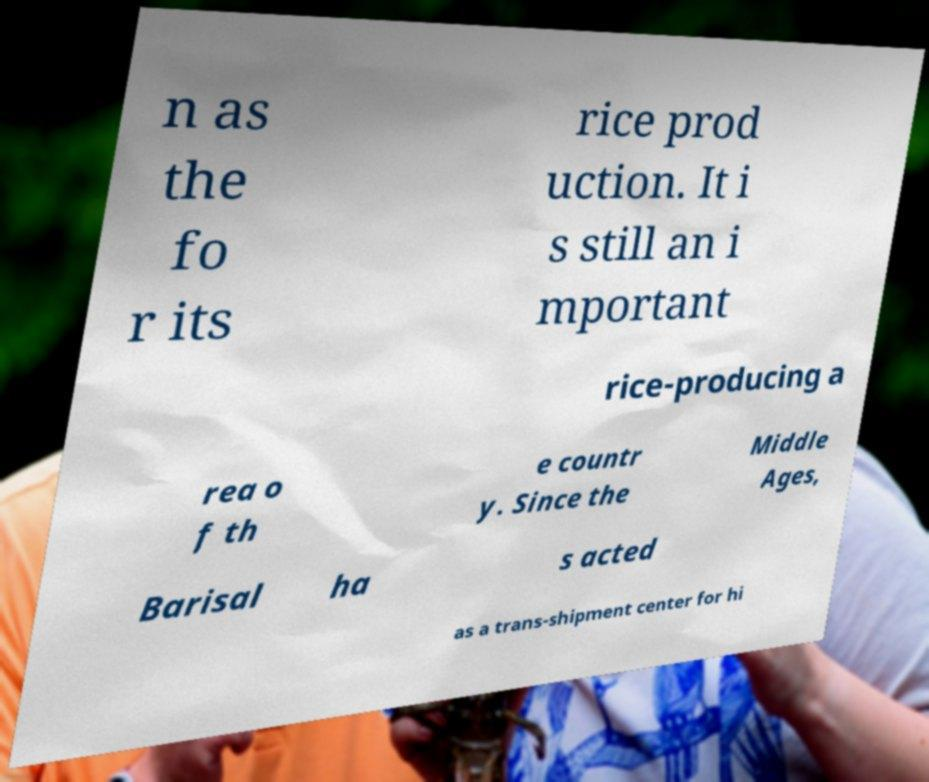What messages or text are displayed in this image? I need them in a readable, typed format. n as the fo r its rice prod uction. It i s still an i mportant rice-producing a rea o f th e countr y. Since the Middle Ages, Barisal ha s acted as a trans-shipment center for hi 